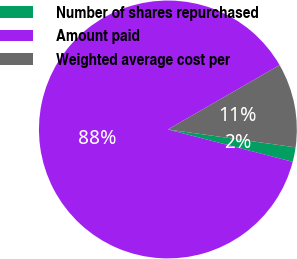Convert chart. <chart><loc_0><loc_0><loc_500><loc_500><pie_chart><fcel>Number of shares repurchased<fcel>Amount paid<fcel>Weighted average cost per<nl><fcel>1.82%<fcel>87.64%<fcel>10.54%<nl></chart> 